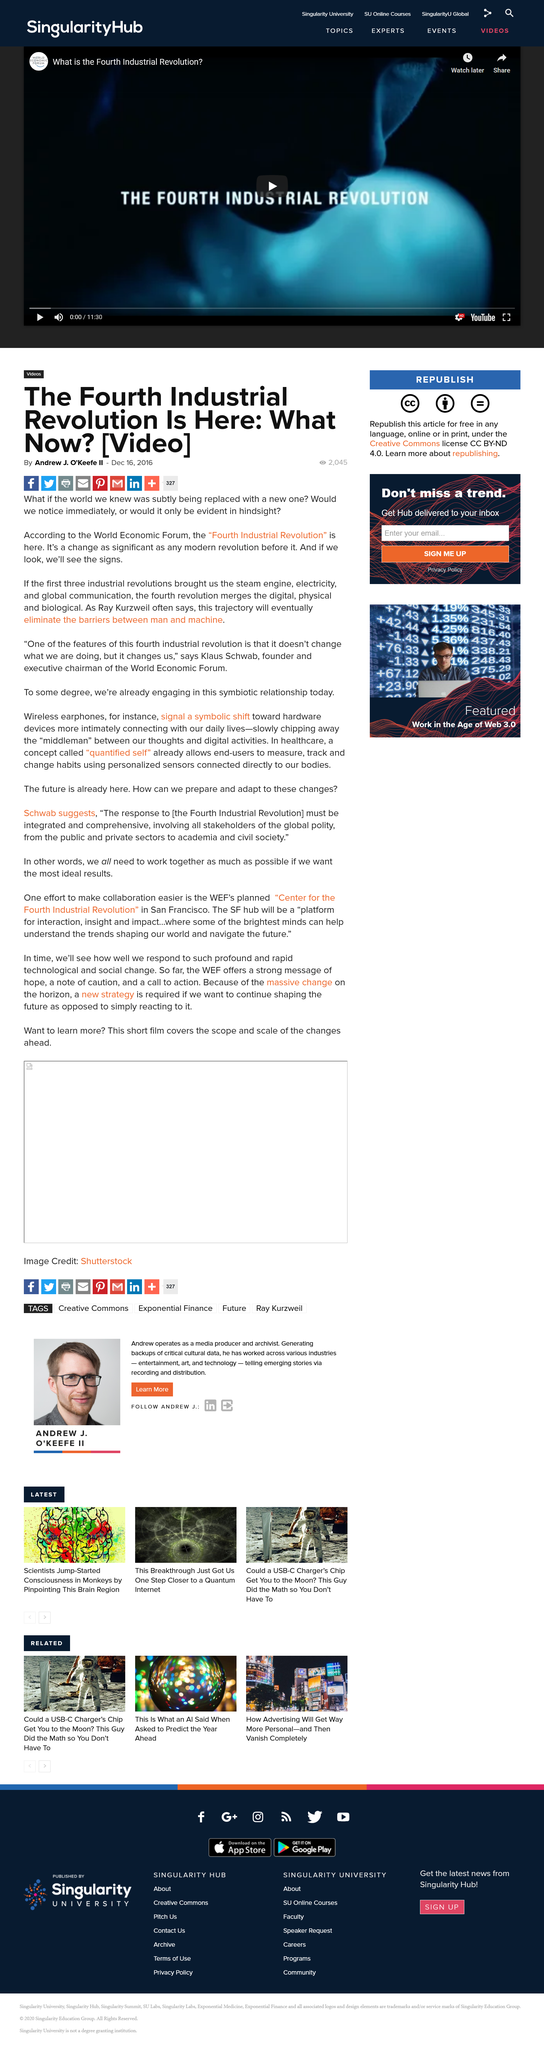Highlight a few significant elements in this photo. The article on the fourth industrial revolution being here was published on December 16, 2016. The article on the fourth industrial revolution being present was written by Andrew J. O'Keefe II. Klaus Schwab is the founder and executive chairman of the World Economic Forum. 